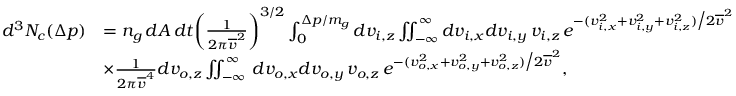Convert formula to latex. <formula><loc_0><loc_0><loc_500><loc_500>\begin{array} { r l } { d ^ { 3 } N _ { c } ( \Delta p ) } & { = n _ { g } \, d A \, d t \left ( \frac { 1 } { 2 \pi \overline { v } ^ { 2 } } \right ) ^ { 3 / 2 } \int _ { 0 } ^ { \Delta p / m _ { g } } d v _ { i , z } \iint _ { - \infty } ^ { \infty } d v _ { i , x } d v _ { i , y } \, v _ { i , z } \, e ^ { - ( v _ { i , x } ^ { 2 } + v _ { i , y } ^ { 2 } + v _ { i , z } ^ { 2 } ) \Big / 2 \overline { v } ^ { 2 } } } \\ & { \times \frac { 1 } { 2 \pi \overline { v } ^ { 4 } } d v _ { o , z } \iint _ { - \infty } ^ { \infty } \, d v _ { o , x } d v _ { o , y } \, v _ { o , z } \, e ^ { - ( v _ { o , x } ^ { 2 } + v _ { o , y } ^ { 2 } + v _ { o , z } ^ { 2 } ) \Big / 2 \overline { v } ^ { 2 } } , } \end{array}</formula> 